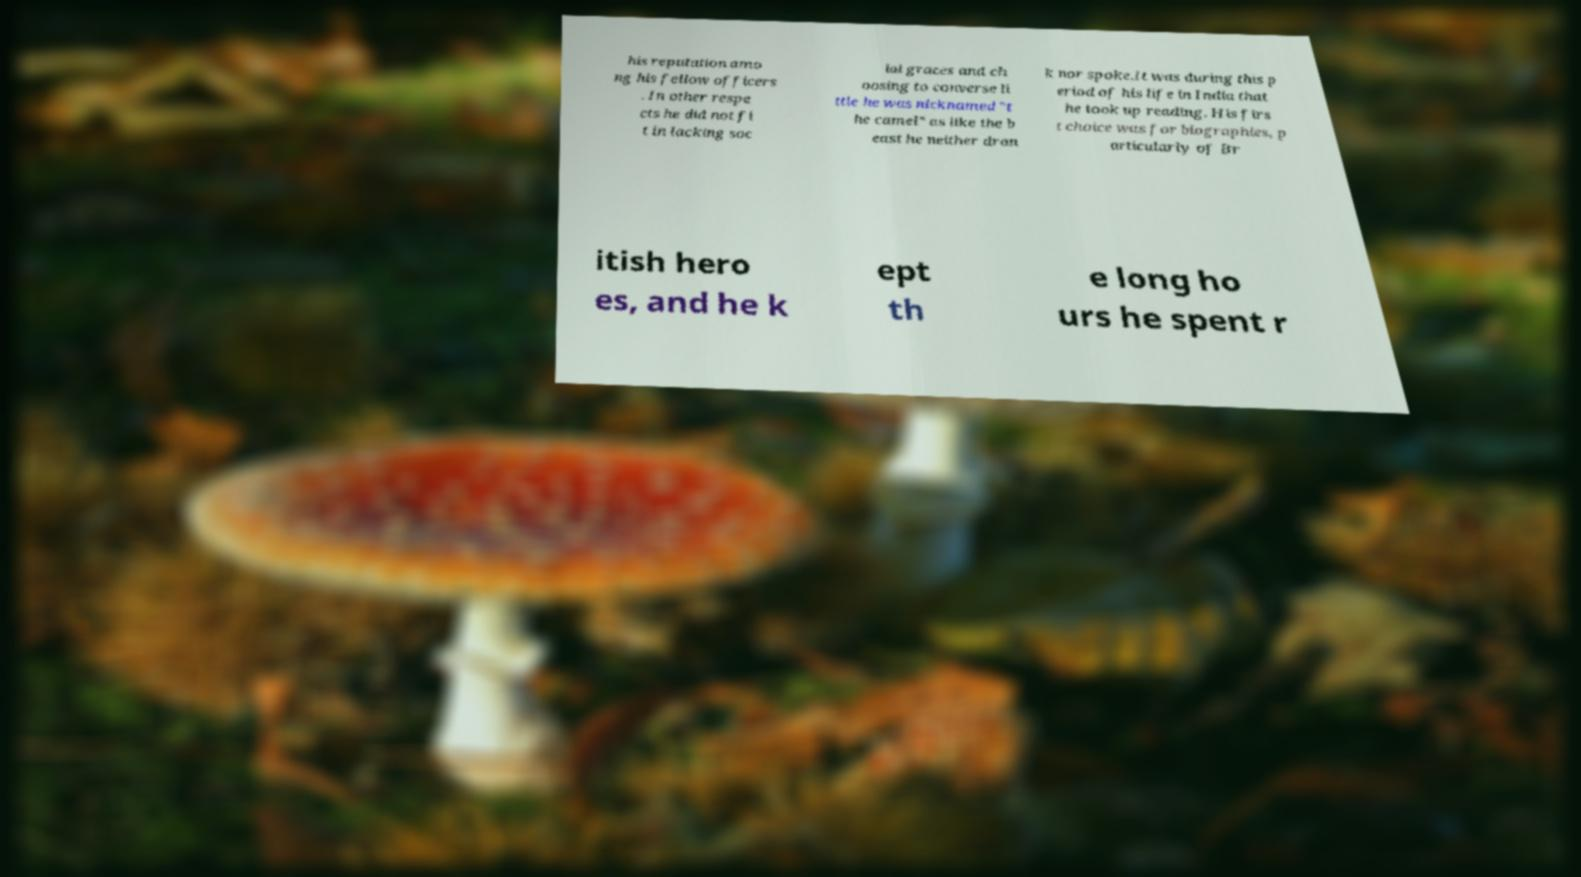What messages or text are displayed in this image? I need them in a readable, typed format. his reputation amo ng his fellow officers . In other respe cts he did not fi t in lacking soc ial graces and ch oosing to converse li ttle he was nicknamed "t he camel" as like the b east he neither dran k nor spoke.It was during this p eriod of his life in India that he took up reading. His firs t choice was for biographies, p articularly of Br itish hero es, and he k ept th e long ho urs he spent r 